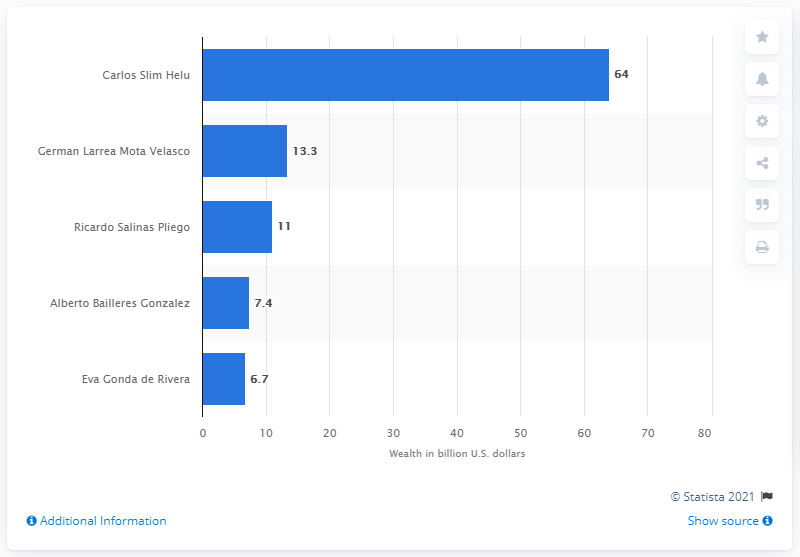Point out several critical features in this image. Carlos Slim Helu was the wealthiest person in Mexico in 2019. 